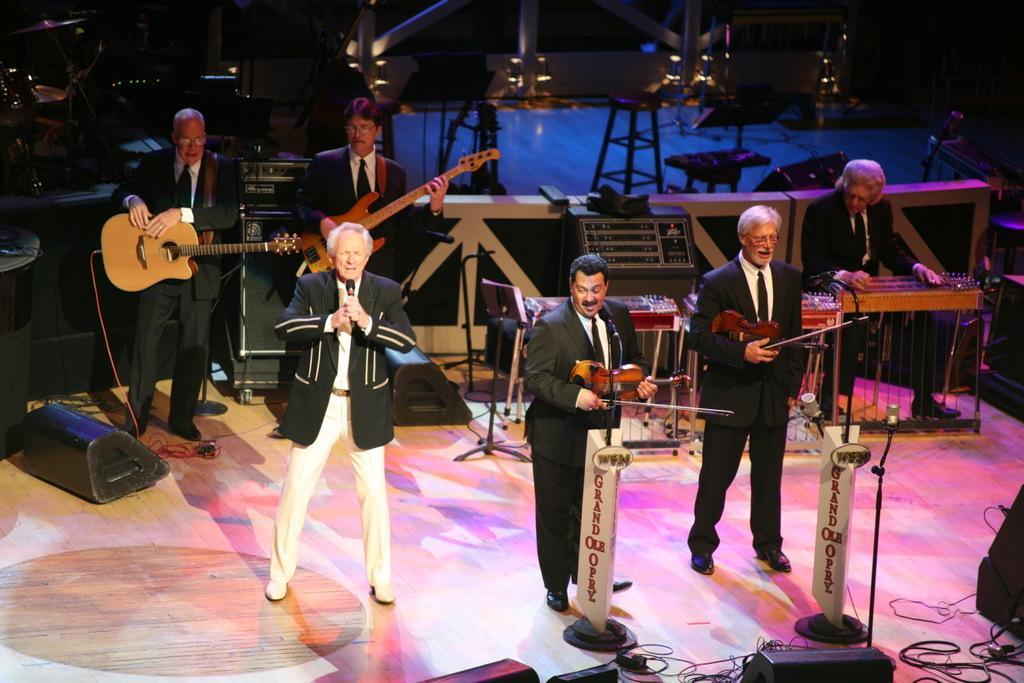Describe this image in one or two sentences. Here we can see a six people who are performing on a stage. They are playing a guitar and singing on a microphone. 